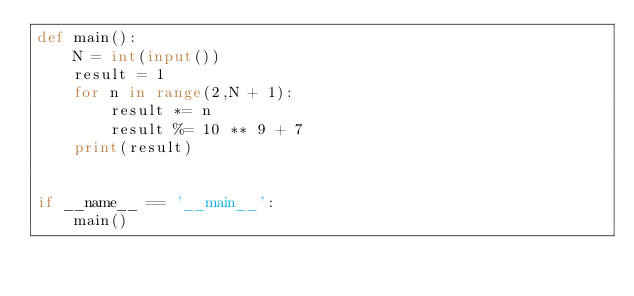<code> <loc_0><loc_0><loc_500><loc_500><_Python_>def main():
    N = int(input())
    result = 1
    for n in range(2,N + 1):
        result *= n
        result %= 10 ** 9 + 7
    print(result)


if __name__ == '__main__':
    main()
</code> 